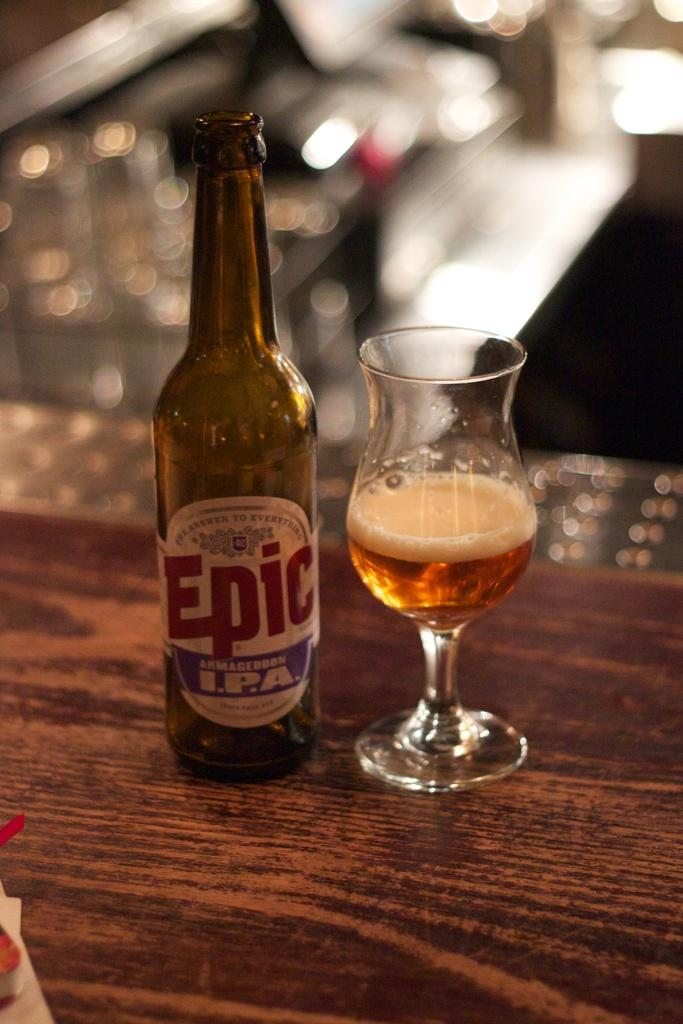<image>
Present a compact description of the photo's key features. A bottle of Epic beer sits next to an almost completely drained glass. 